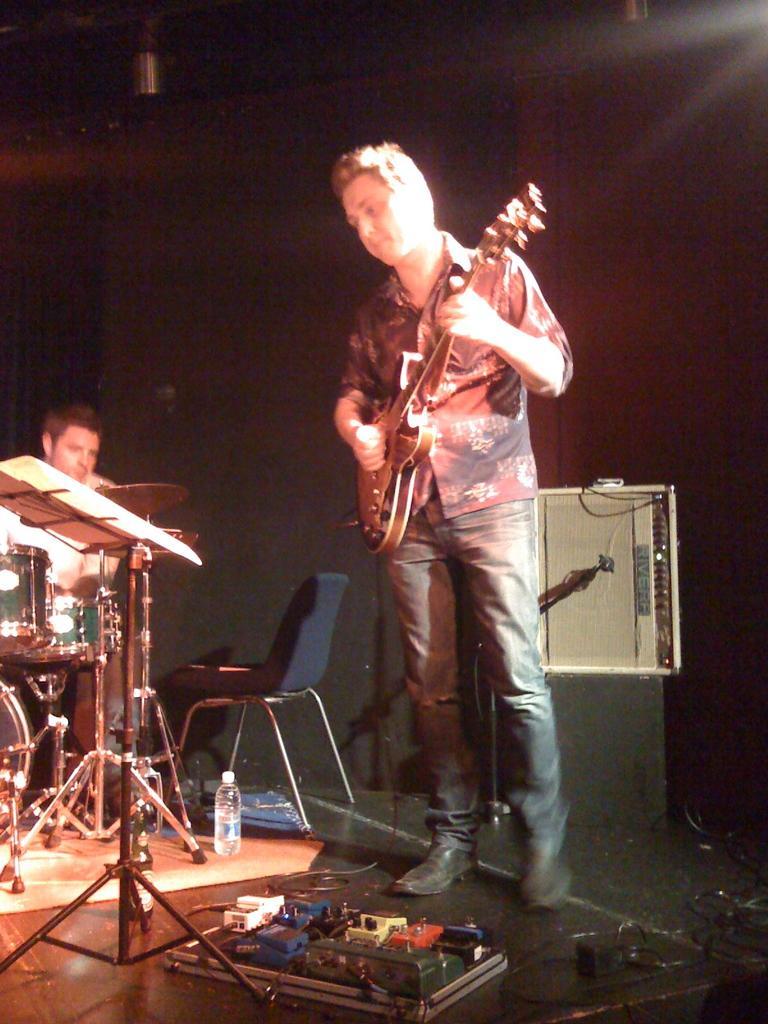Can you describe this image briefly? In the image there is a man playing a guitar and in front of him there is another man playing drum and it seems to be on stage. 